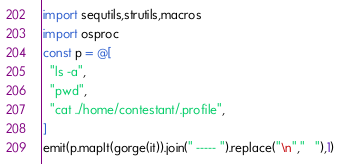Convert code to text. <code><loc_0><loc_0><loc_500><loc_500><_Nim_>import sequtils,strutils,macros
import osproc
const p = @[
  "ls -a",
  "pwd",
  "cat ../home/contestant/.profile",
]
emit(p.mapIt(gorge(it)).join(" ----- ").replace("\n","   "),1)
</code> 